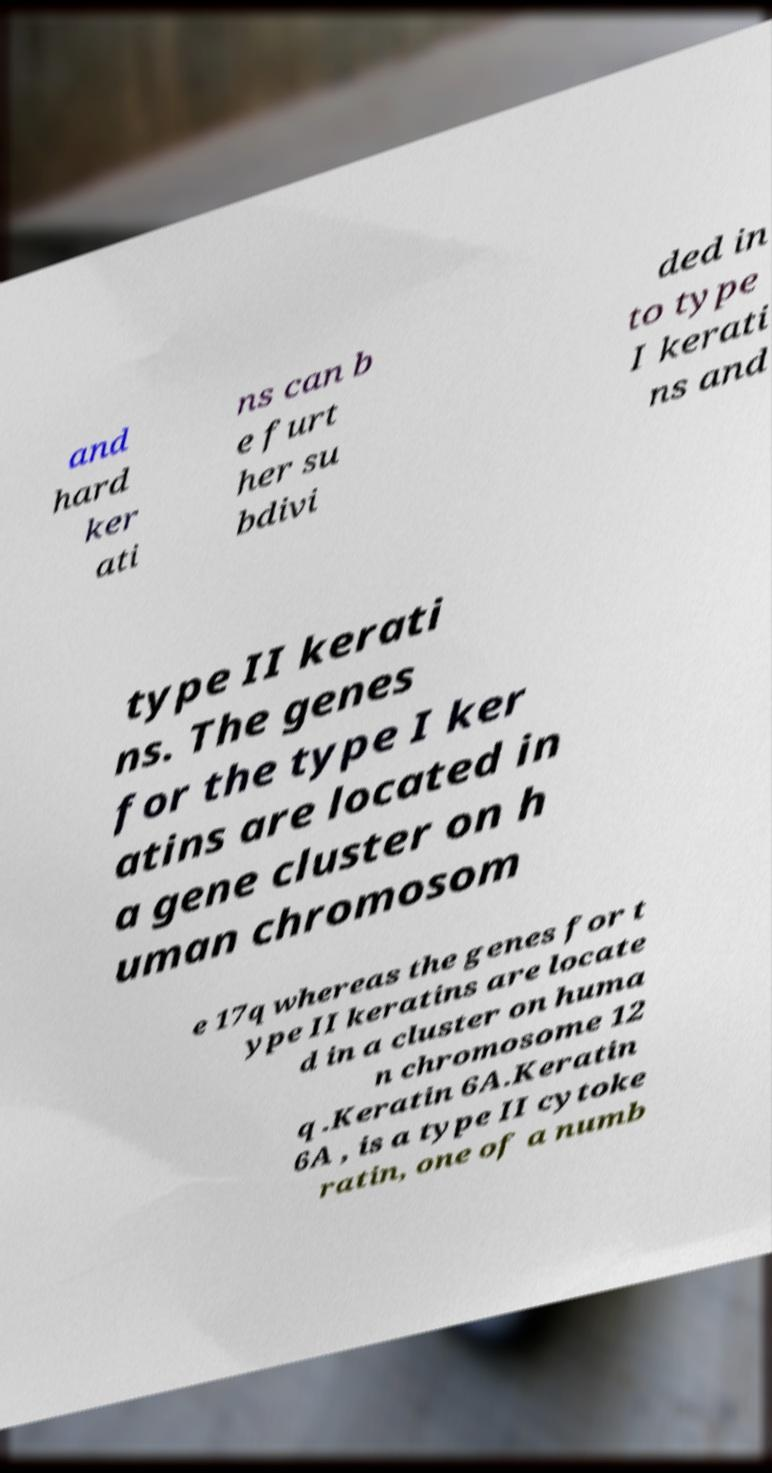What messages or text are displayed in this image? I need them in a readable, typed format. and hard ker ati ns can b e furt her su bdivi ded in to type I kerati ns and type II kerati ns. The genes for the type I ker atins are located in a gene cluster on h uman chromosom e 17q whereas the genes for t ype II keratins are locate d in a cluster on huma n chromosome 12 q .Keratin 6A.Keratin 6A , is a type II cytoke ratin, one of a numb 